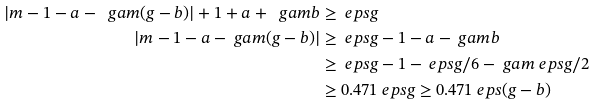Convert formula to latex. <formula><loc_0><loc_0><loc_500><loc_500>| m - 1 - a - \ g a m ( g - b ) | + 1 + a + \ g a m b & \geq \ e p s g \\ | m - 1 - a - \ g a m ( g - b ) | & \geq \ e p s g - 1 - a - \ g a m b \\ & \geq \ e p s g - 1 - \ e p s g / 6 - \ g a m \ e p s g / 2 \\ & \geq 0 . 4 7 1 \ e p s g \geq 0 . 4 7 1 \ e p s ( g - b )</formula> 